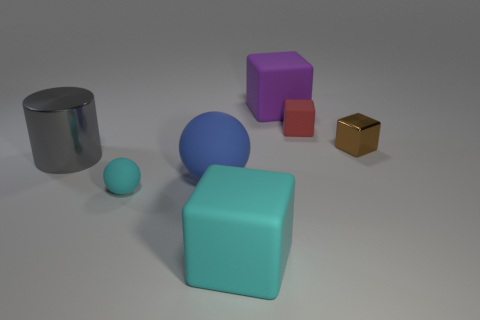What is the shape of the tiny matte object that is in front of the rubber ball behind the tiny cyan matte sphere?
Provide a short and direct response. Sphere. How many cylinders are the same size as the cyan matte cube?
Your answer should be compact. 1. Is there a cyan cube?
Provide a succinct answer. Yes. Are there any other things that have the same color as the small matte cube?
Offer a very short reply. No. What shape is the small cyan object that is made of the same material as the small red cube?
Your answer should be very brief. Sphere. What is the color of the big matte cube behind the large cube left of the big rubber thing that is behind the gray shiny cylinder?
Give a very brief answer. Purple. Is the number of big purple rubber objects behind the big purple rubber cube the same as the number of red metallic cubes?
Keep it short and to the point. Yes. Is the color of the tiny rubber sphere the same as the large cube that is in front of the red block?
Provide a short and direct response. Yes. Is there a matte thing that is behind the small rubber thing on the right side of the small thing to the left of the purple cube?
Your answer should be very brief. Yes. Are there fewer rubber objects that are to the right of the blue matte ball than big purple matte cylinders?
Your answer should be compact. No. 